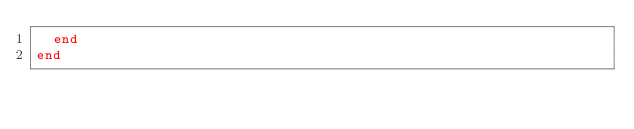<code> <loc_0><loc_0><loc_500><loc_500><_Ruby_>  end
end
</code> 